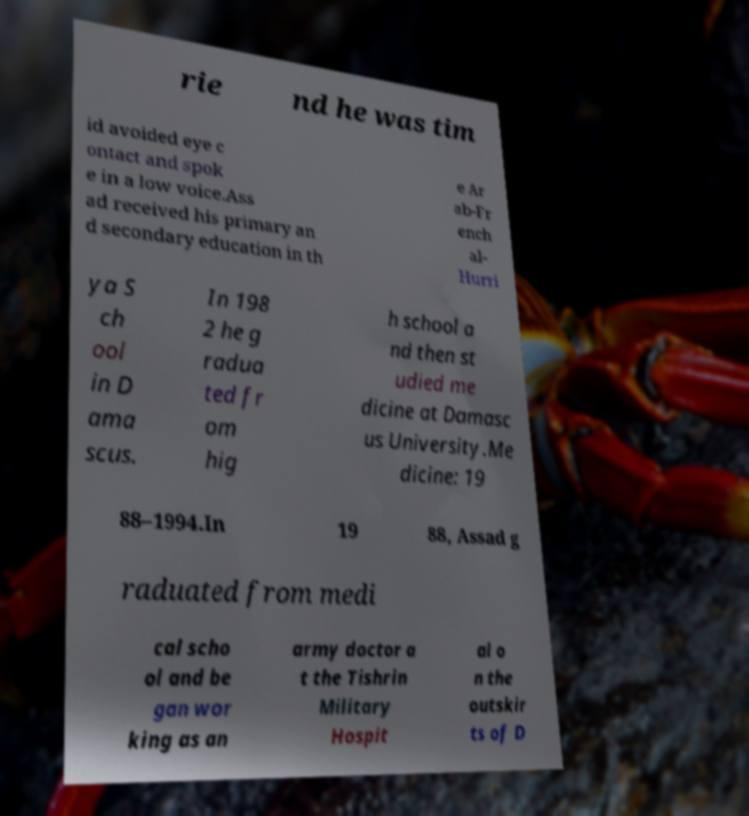Please identify and transcribe the text found in this image. rie nd he was tim id avoided eye c ontact and spok e in a low voice.Ass ad received his primary an d secondary education in th e Ar ab-Fr ench al- Hurri ya S ch ool in D ama scus. In 198 2 he g radua ted fr om hig h school a nd then st udied me dicine at Damasc us University.Me dicine: 19 88–1994.In 19 88, Assad g raduated from medi cal scho ol and be gan wor king as an army doctor a t the Tishrin Military Hospit al o n the outskir ts of D 